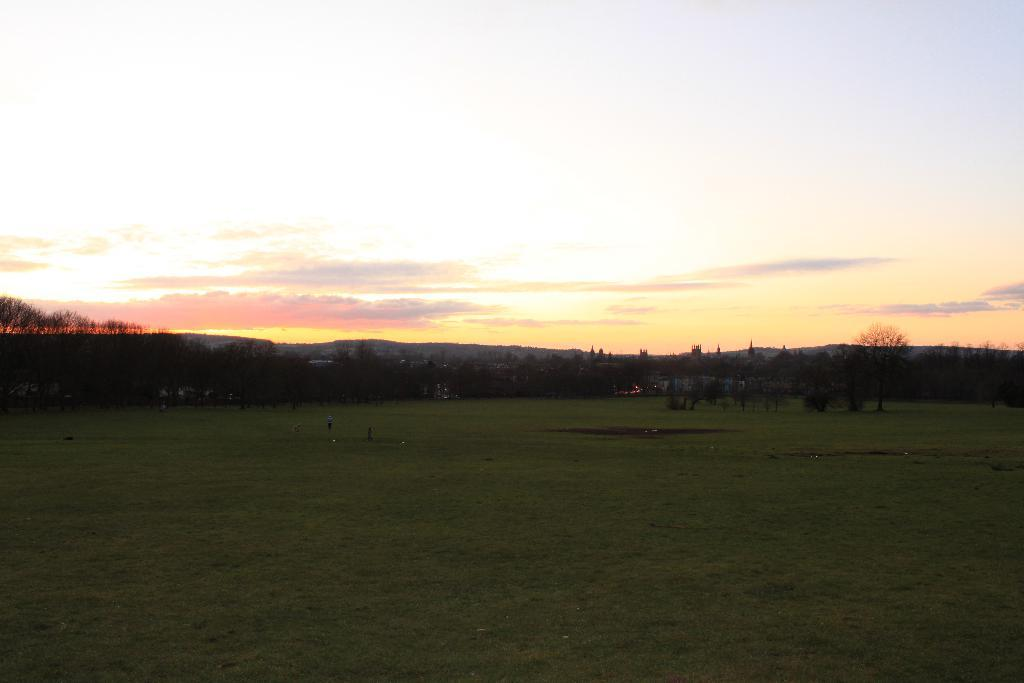What is visible on the ground in the image? The ground is visible in the image. What type of vegetation can be seen in the image? There are trees in the image. What geographical features are present in the image? There are hills in the image. What is visible in the sky in the image? The sky is visible in the image, and clouds are present. How many strings are attached to the trees in the image? There are no strings attached to the trees in the image. What type of animal can be seen grazing in the image? There is no animal, such as a deer, present in the image. 